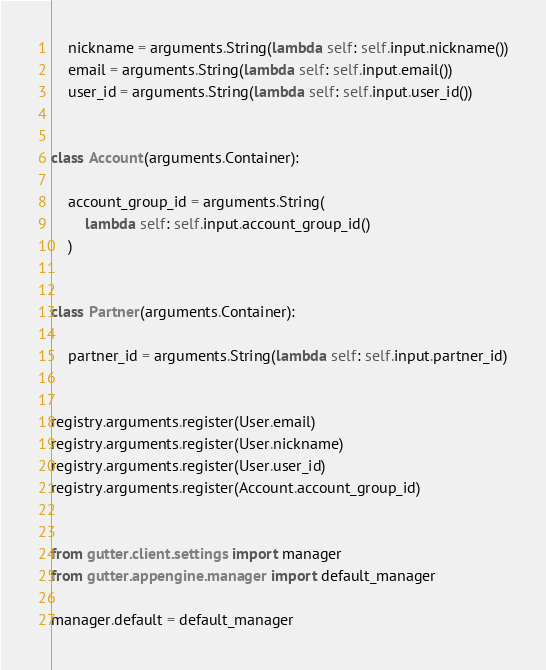Convert code to text. <code><loc_0><loc_0><loc_500><loc_500><_Python_>    nickname = arguments.String(lambda self: self.input.nickname())
    email = arguments.String(lambda self: self.input.email())
    user_id = arguments.String(lambda self: self.input.user_id())


class Account(arguments.Container):

    account_group_id = arguments.String(
        lambda self: self.input.account_group_id()
    )


class Partner(arguments.Container):

    partner_id = arguments.String(lambda self: self.input.partner_id)


registry.arguments.register(User.email)
registry.arguments.register(User.nickname)
registry.arguments.register(User.user_id)
registry.arguments.register(Account.account_group_id)


from gutter.client.settings import manager
from gutter.appengine.manager import default_manager

manager.default = default_manager
</code> 